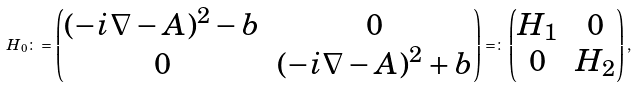<formula> <loc_0><loc_0><loc_500><loc_500>H _ { 0 } \colon = \begin{pmatrix} ( - i \nabla - A ) ^ { 2 } - b & 0 \\ 0 & ( - i \nabla - A ) ^ { 2 } + b \end{pmatrix} = \colon \begin{pmatrix} H _ { 1 } & 0 \\ 0 & H _ { 2 } \end{pmatrix} ,</formula> 